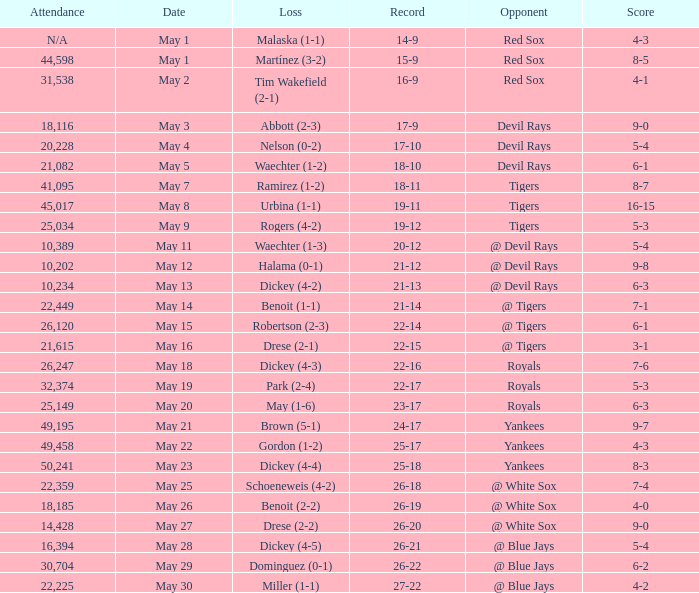What was the score of the game that had a loss of Drese (2-2)? 9-0. 